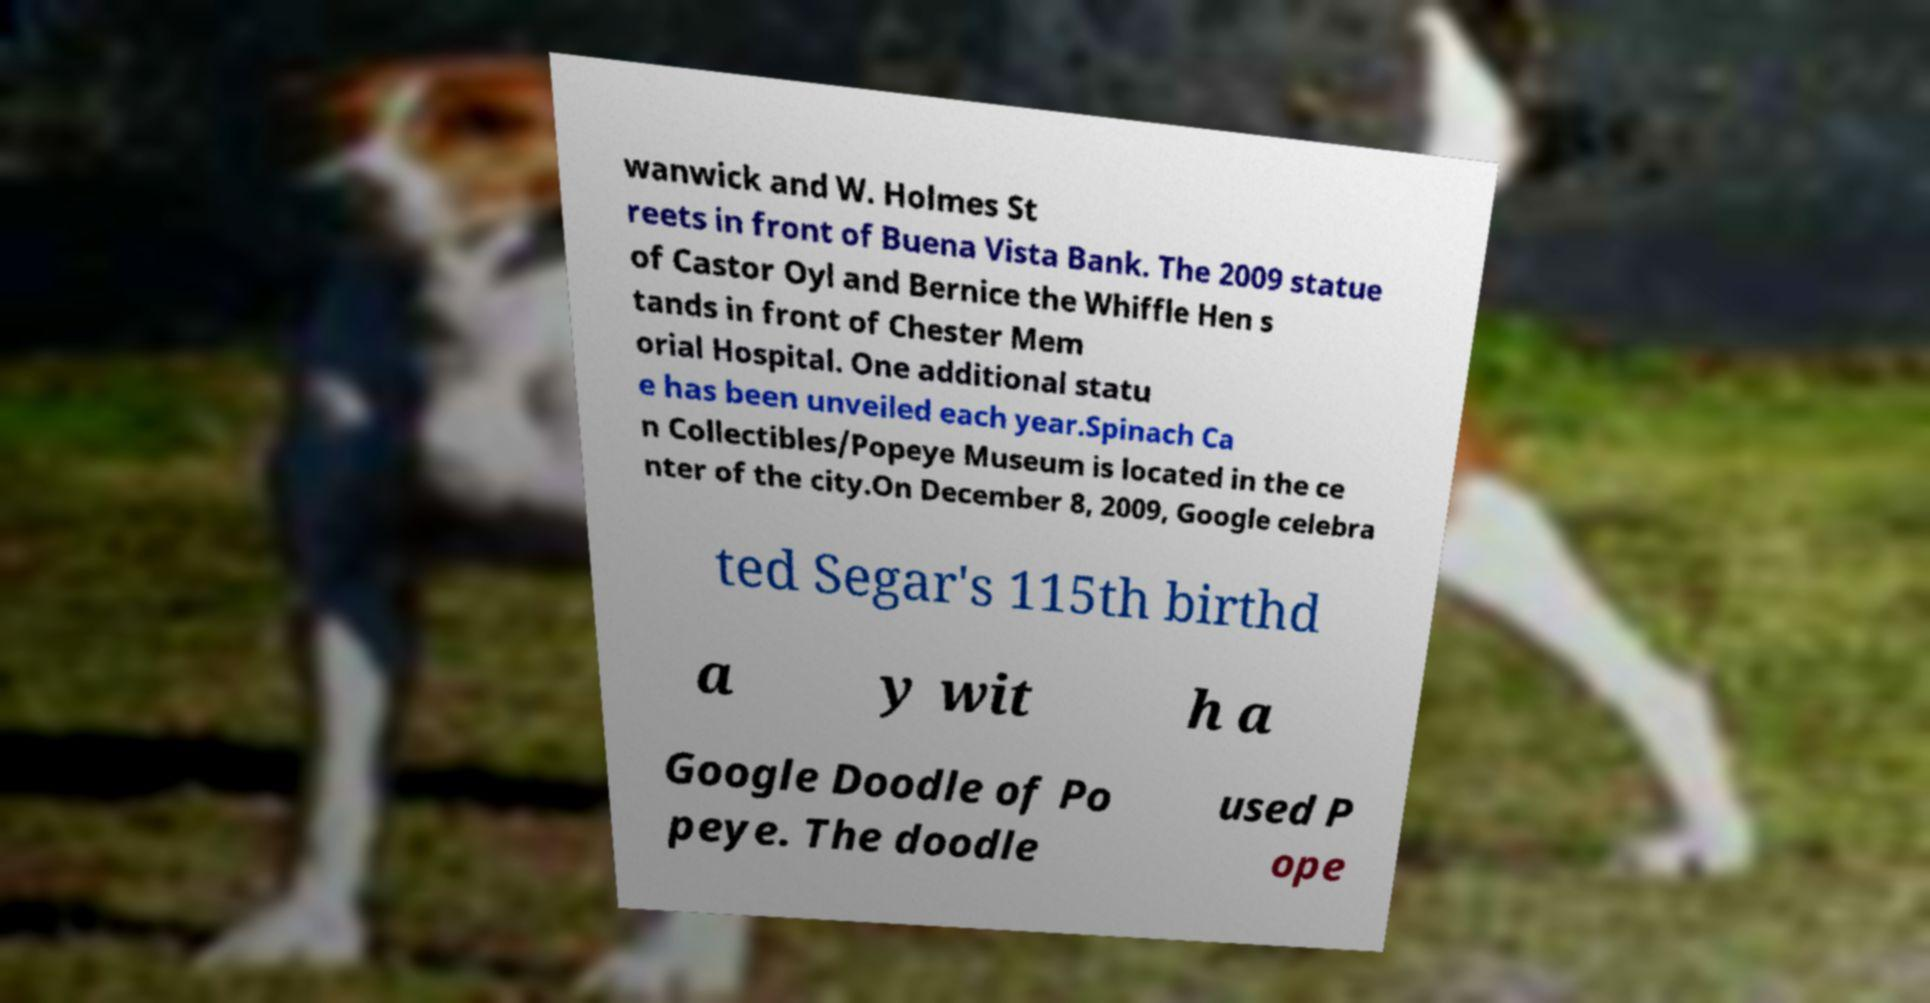Could you extract and type out the text from this image? wanwick and W. Holmes St reets in front of Buena Vista Bank. The 2009 statue of Castor Oyl and Bernice the Whiffle Hen s tands in front of Chester Mem orial Hospital. One additional statu e has been unveiled each year.Spinach Ca n Collectibles/Popeye Museum is located in the ce nter of the city.On December 8, 2009, Google celebra ted Segar's 115th birthd a y wit h a Google Doodle of Po peye. The doodle used P ope 